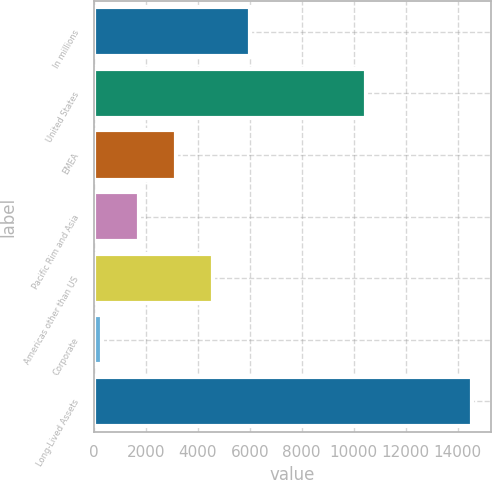Convert chart. <chart><loc_0><loc_0><loc_500><loc_500><bar_chart><fcel>In millions<fcel>United States<fcel>EMEA<fcel>Pacific Rim and Asia<fcel>Americas other than US<fcel>Corporate<fcel>Long-Lived Assets<nl><fcel>6014.4<fcel>10484<fcel>3162.2<fcel>1736.1<fcel>4588.3<fcel>310<fcel>14571<nl></chart> 